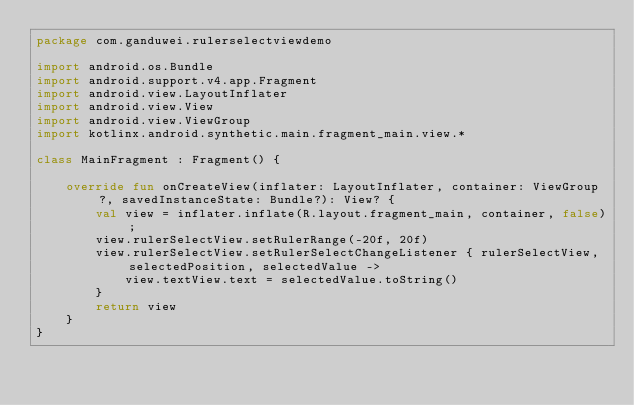Convert code to text. <code><loc_0><loc_0><loc_500><loc_500><_Kotlin_>package com.ganduwei.rulerselectviewdemo

import android.os.Bundle
import android.support.v4.app.Fragment
import android.view.LayoutInflater
import android.view.View
import android.view.ViewGroup
import kotlinx.android.synthetic.main.fragment_main.view.*

class MainFragment : Fragment() {

    override fun onCreateView(inflater: LayoutInflater, container: ViewGroup?, savedInstanceState: Bundle?): View? {
        val view = inflater.inflate(R.layout.fragment_main, container, false);
        view.rulerSelectView.setRulerRange(-20f, 20f)
        view.rulerSelectView.setRulerSelectChangeListener { rulerSelectView, selectedPosition, selectedValue ->
            view.textView.text = selectedValue.toString()
        }
        return view
    }
}</code> 